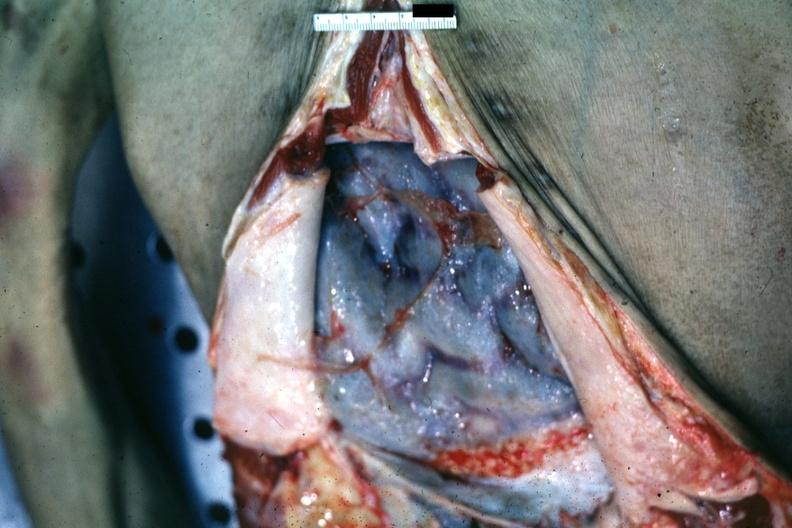s tuberculous peritonitis present?
Answer the question using a single word or phrase. No 